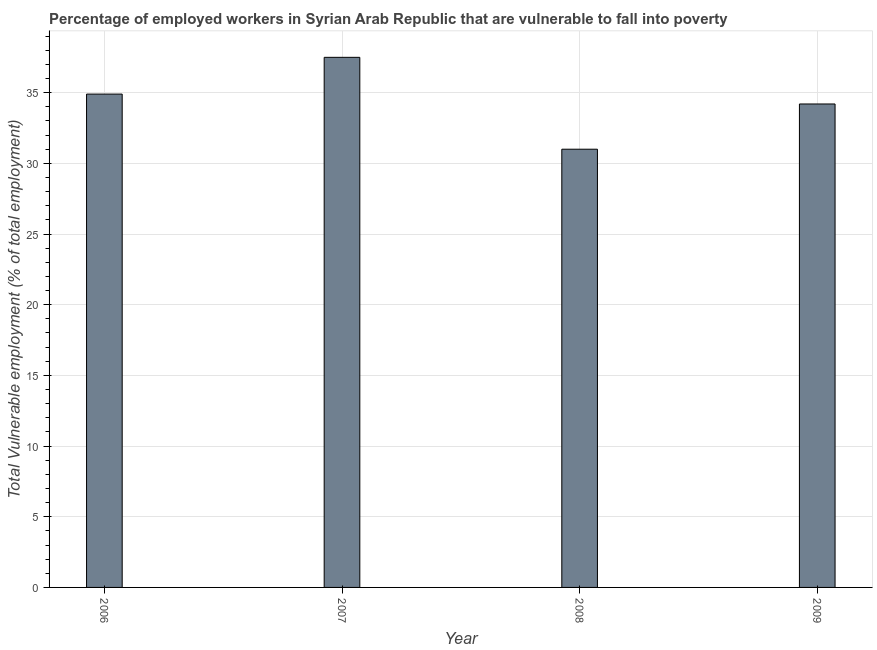Does the graph contain any zero values?
Provide a short and direct response. No. Does the graph contain grids?
Keep it short and to the point. Yes. What is the title of the graph?
Give a very brief answer. Percentage of employed workers in Syrian Arab Republic that are vulnerable to fall into poverty. What is the label or title of the X-axis?
Offer a very short reply. Year. What is the label or title of the Y-axis?
Your answer should be compact. Total Vulnerable employment (% of total employment). What is the total vulnerable employment in 2006?
Offer a terse response. 34.9. Across all years, what is the maximum total vulnerable employment?
Give a very brief answer. 37.5. Across all years, what is the minimum total vulnerable employment?
Offer a terse response. 31. In which year was the total vulnerable employment maximum?
Your answer should be compact. 2007. In which year was the total vulnerable employment minimum?
Your response must be concise. 2008. What is the sum of the total vulnerable employment?
Make the answer very short. 137.6. What is the difference between the total vulnerable employment in 2007 and 2008?
Provide a short and direct response. 6.5. What is the average total vulnerable employment per year?
Your answer should be very brief. 34.4. What is the median total vulnerable employment?
Offer a very short reply. 34.55. In how many years, is the total vulnerable employment greater than 15 %?
Offer a terse response. 4. Is the total vulnerable employment in 2007 less than that in 2009?
Give a very brief answer. No. What is the difference between the highest and the second highest total vulnerable employment?
Offer a terse response. 2.6. Is the sum of the total vulnerable employment in 2006 and 2008 greater than the maximum total vulnerable employment across all years?
Provide a short and direct response. Yes. In how many years, is the total vulnerable employment greater than the average total vulnerable employment taken over all years?
Your answer should be compact. 2. Are all the bars in the graph horizontal?
Ensure brevity in your answer.  No. What is the difference between two consecutive major ticks on the Y-axis?
Give a very brief answer. 5. Are the values on the major ticks of Y-axis written in scientific E-notation?
Make the answer very short. No. What is the Total Vulnerable employment (% of total employment) in 2006?
Ensure brevity in your answer.  34.9. What is the Total Vulnerable employment (% of total employment) in 2007?
Offer a terse response. 37.5. What is the Total Vulnerable employment (% of total employment) in 2009?
Your answer should be compact. 34.2. What is the difference between the Total Vulnerable employment (% of total employment) in 2006 and 2009?
Offer a very short reply. 0.7. What is the difference between the Total Vulnerable employment (% of total employment) in 2007 and 2008?
Keep it short and to the point. 6.5. What is the ratio of the Total Vulnerable employment (% of total employment) in 2006 to that in 2007?
Keep it short and to the point. 0.93. What is the ratio of the Total Vulnerable employment (% of total employment) in 2006 to that in 2008?
Keep it short and to the point. 1.13. What is the ratio of the Total Vulnerable employment (% of total employment) in 2006 to that in 2009?
Your answer should be compact. 1.02. What is the ratio of the Total Vulnerable employment (% of total employment) in 2007 to that in 2008?
Your answer should be compact. 1.21. What is the ratio of the Total Vulnerable employment (% of total employment) in 2007 to that in 2009?
Your response must be concise. 1.1. What is the ratio of the Total Vulnerable employment (% of total employment) in 2008 to that in 2009?
Provide a succinct answer. 0.91. 